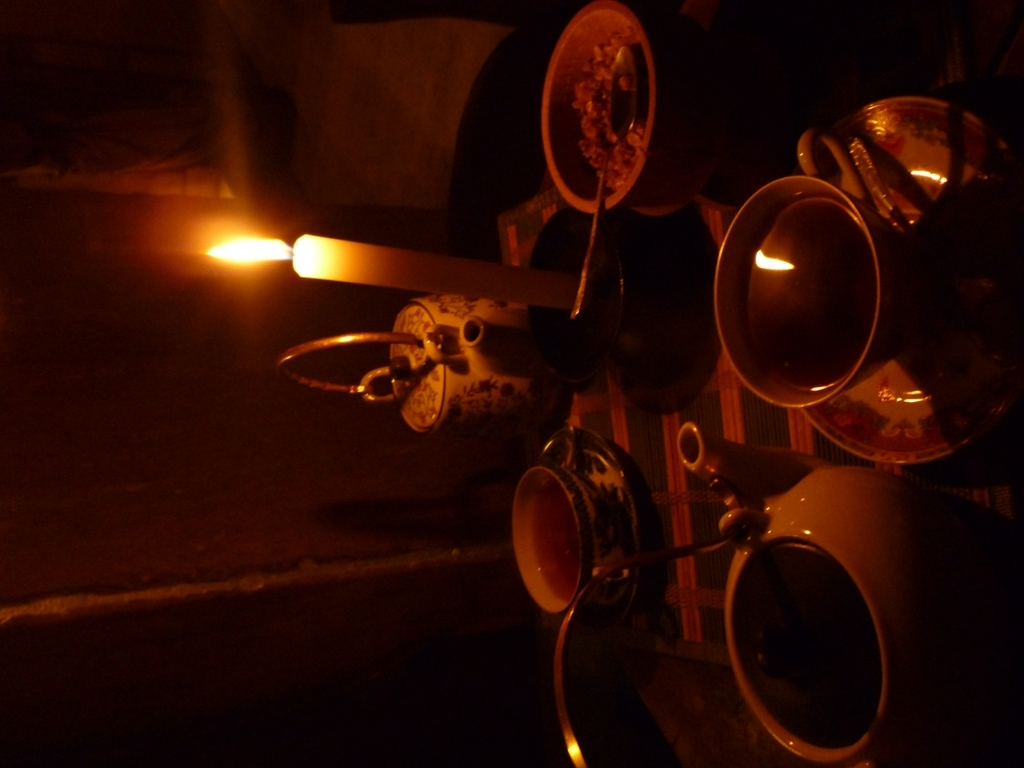Is the clarity of the image acceptable?
A. Yes
B. No
Answer with the option's letter from the given choices directly.
 A. 